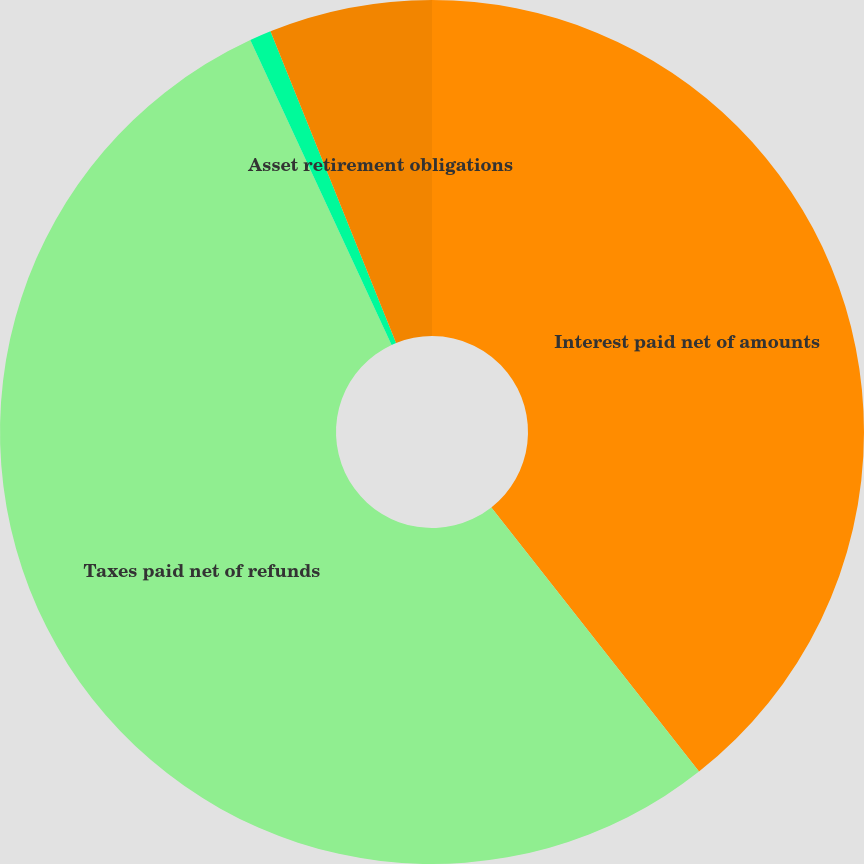Convert chart to OTSL. <chart><loc_0><loc_0><loc_500><loc_500><pie_chart><fcel>Interest paid net of amounts<fcel>Taxes paid net of refunds<fcel>Accrued capital expenditures<fcel>Asset retirement obligations<nl><fcel>39.4%<fcel>53.7%<fcel>0.81%<fcel>6.1%<nl></chart> 